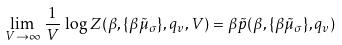<formula> <loc_0><loc_0><loc_500><loc_500>\lim _ { V \rightarrow \infty } \, \frac { 1 } { V } \, \log Z ( \beta , \{ \beta \tilde { \mu } _ { \sigma } \} , q _ { v } , V ) = \beta \tilde { p } ( \beta , \{ \beta \tilde { \mu } _ { \sigma } \} , q _ { v } )</formula> 